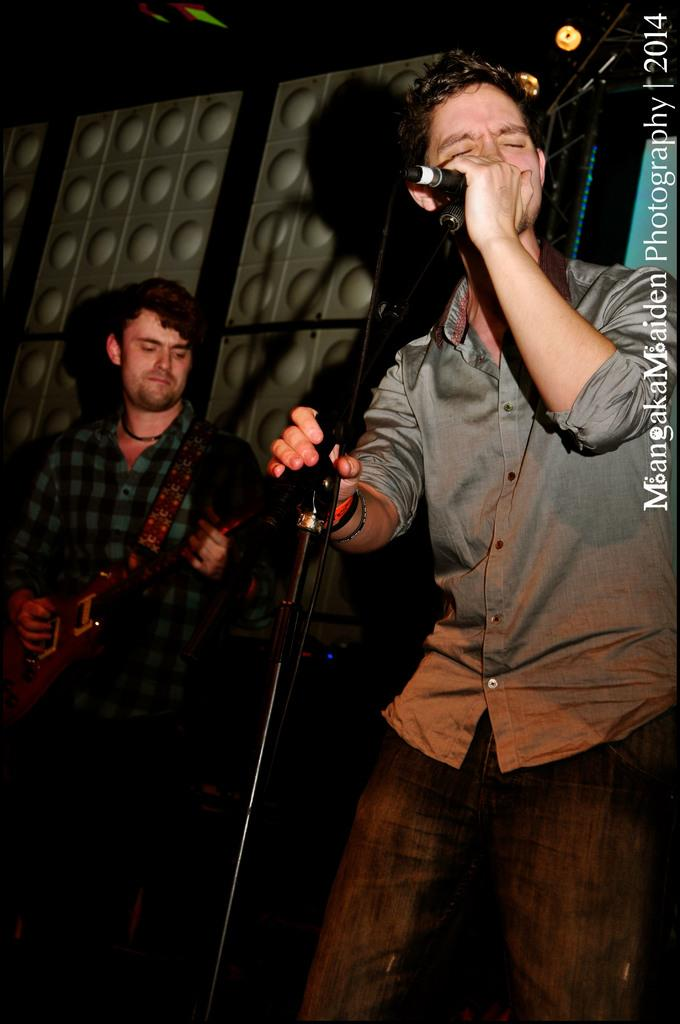How many people are in the image? There are two people in the image. What is the man on the right side holding? The man on the right side is holding a mic. What is the man on the right side doing? The man on the right side is singing a song. What is the man on the left side holding? The man on the left side is holding a guitar. What is the daughter of the man on the left side doing in the image? There is no mention of a daughter in the image, so we cannot answer this question. 